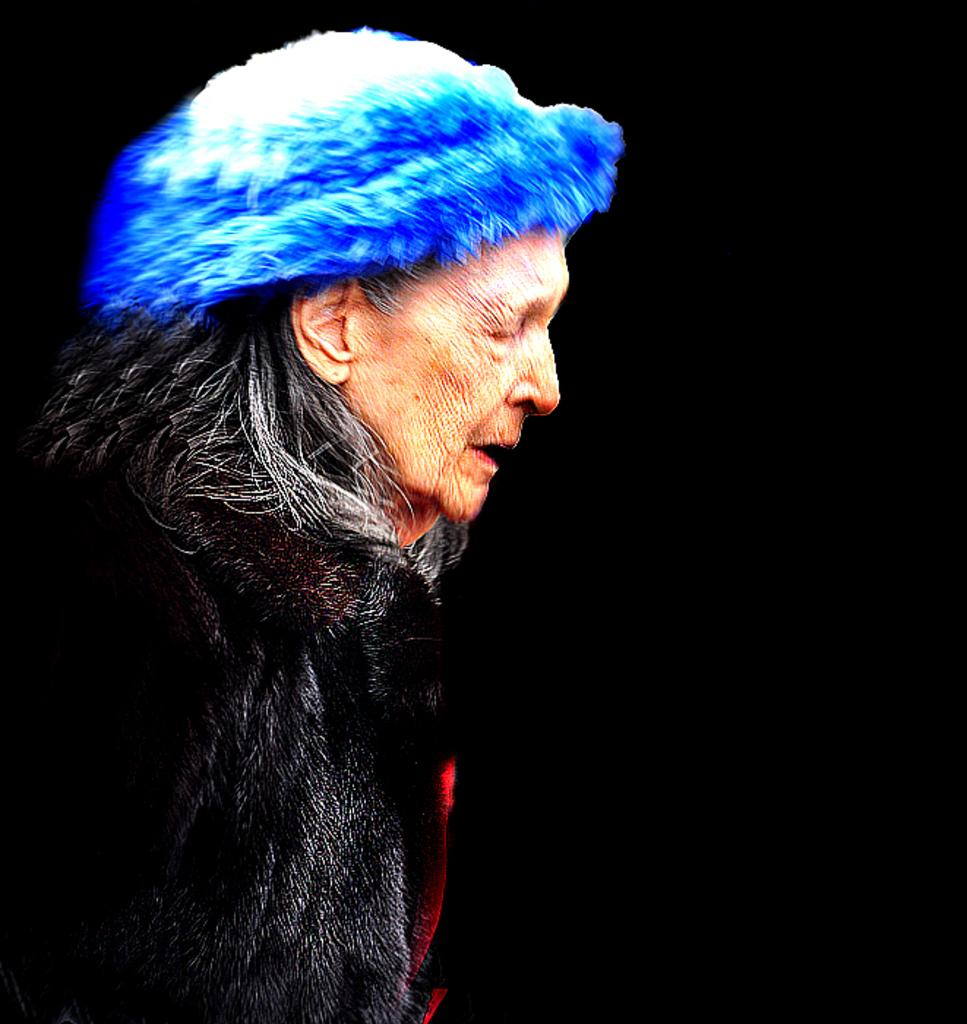What is the main subject of the image? There is an old woman standing in the image. Can you describe the background of the image? The background of the image appears dark. How many oranges are being transported by the train in the image? There is no train or oranges present in the image. 